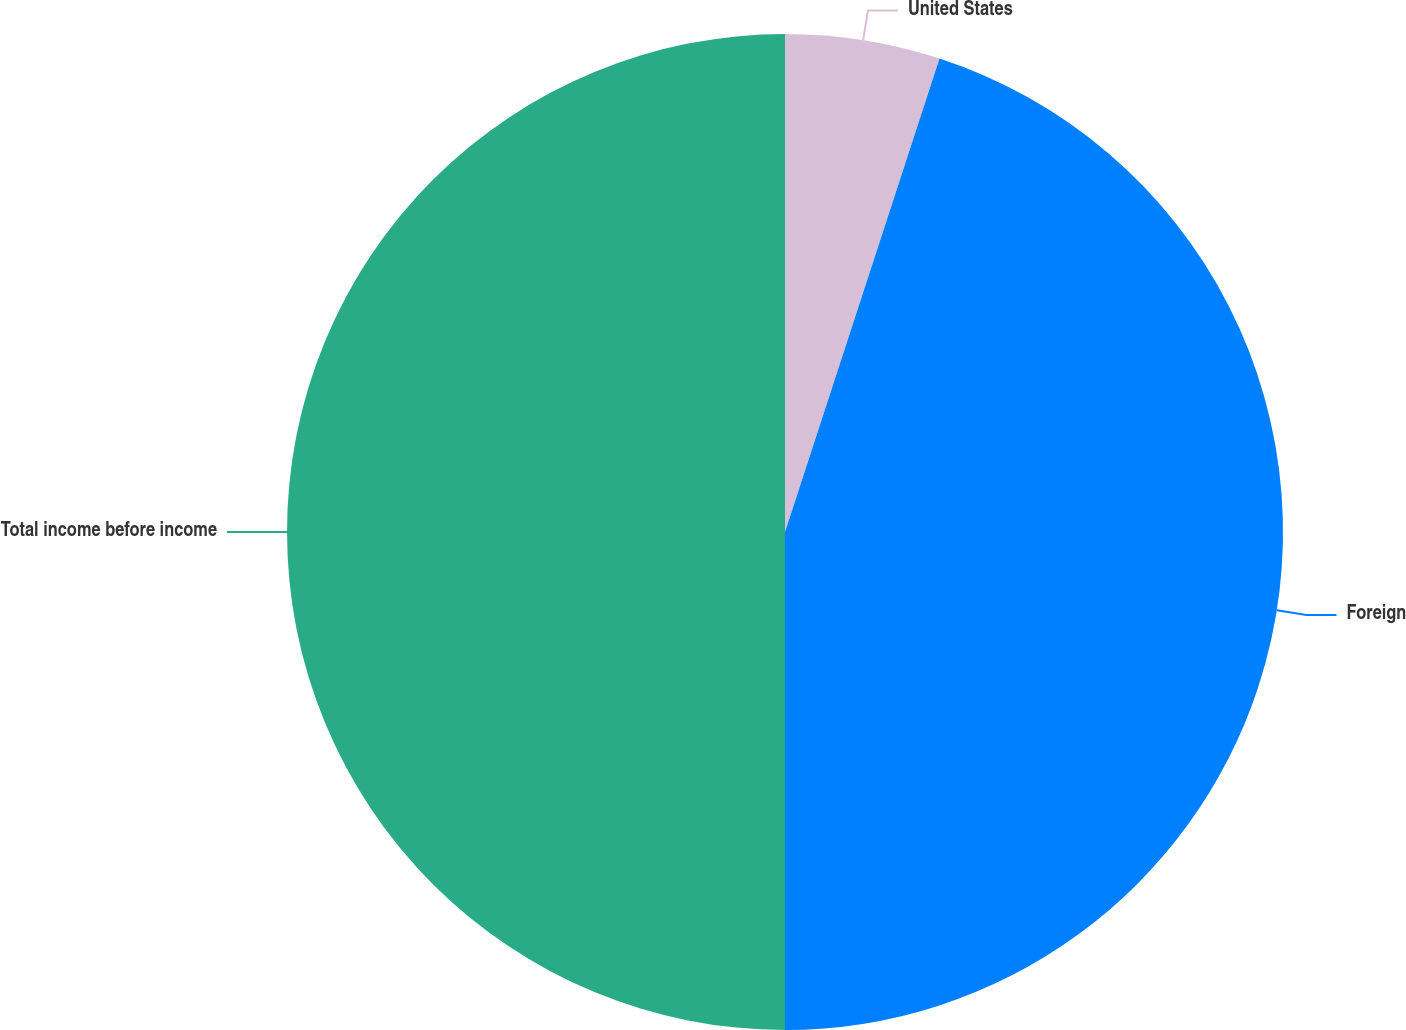Convert chart. <chart><loc_0><loc_0><loc_500><loc_500><pie_chart><fcel>United States<fcel>Foreign<fcel>Total income before income<nl><fcel>5.02%<fcel>44.98%<fcel>50.0%<nl></chart> 